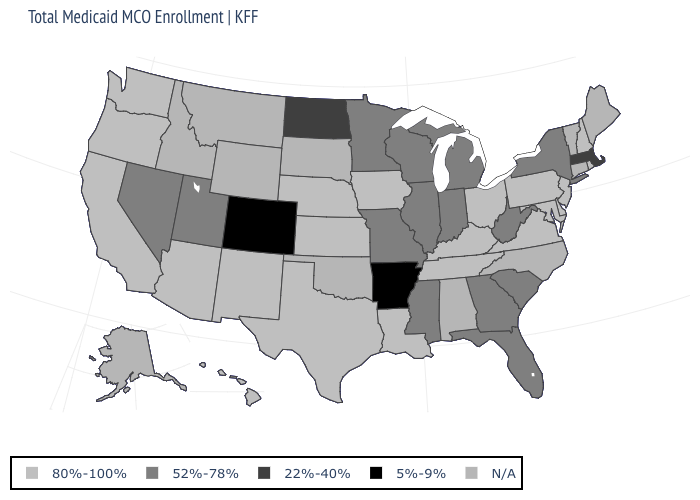Name the states that have a value in the range N/A?
Concise answer only. Alabama, Alaska, Connecticut, Idaho, Maine, Montana, North Carolina, Oklahoma, South Dakota, Vermont, Wyoming. Is the legend a continuous bar?
Be succinct. No. What is the highest value in the USA?
Short answer required. 80%-100%. What is the value of New Hampshire?
Be succinct. 80%-100%. Among the states that border Tennessee , which have the highest value?
Write a very short answer. Kentucky, Virginia. What is the value of Arizona?
Answer briefly. 80%-100%. Name the states that have a value in the range 5%-9%?
Keep it brief. Arkansas, Colorado. Name the states that have a value in the range 80%-100%?
Quick response, please. Arizona, California, Delaware, Hawaii, Iowa, Kansas, Kentucky, Louisiana, Maryland, Nebraska, New Hampshire, New Jersey, New Mexico, Ohio, Oregon, Pennsylvania, Rhode Island, Tennessee, Texas, Virginia, Washington. Name the states that have a value in the range 5%-9%?
Concise answer only. Arkansas, Colorado. Does Arkansas have the lowest value in the USA?
Short answer required. Yes. What is the value of Oklahoma?
Be succinct. N/A. What is the value of Rhode Island?
Short answer required. 80%-100%. Name the states that have a value in the range N/A?
Quick response, please. Alabama, Alaska, Connecticut, Idaho, Maine, Montana, North Carolina, Oklahoma, South Dakota, Vermont, Wyoming. What is the value of Wisconsin?
Quick response, please. 52%-78%. 